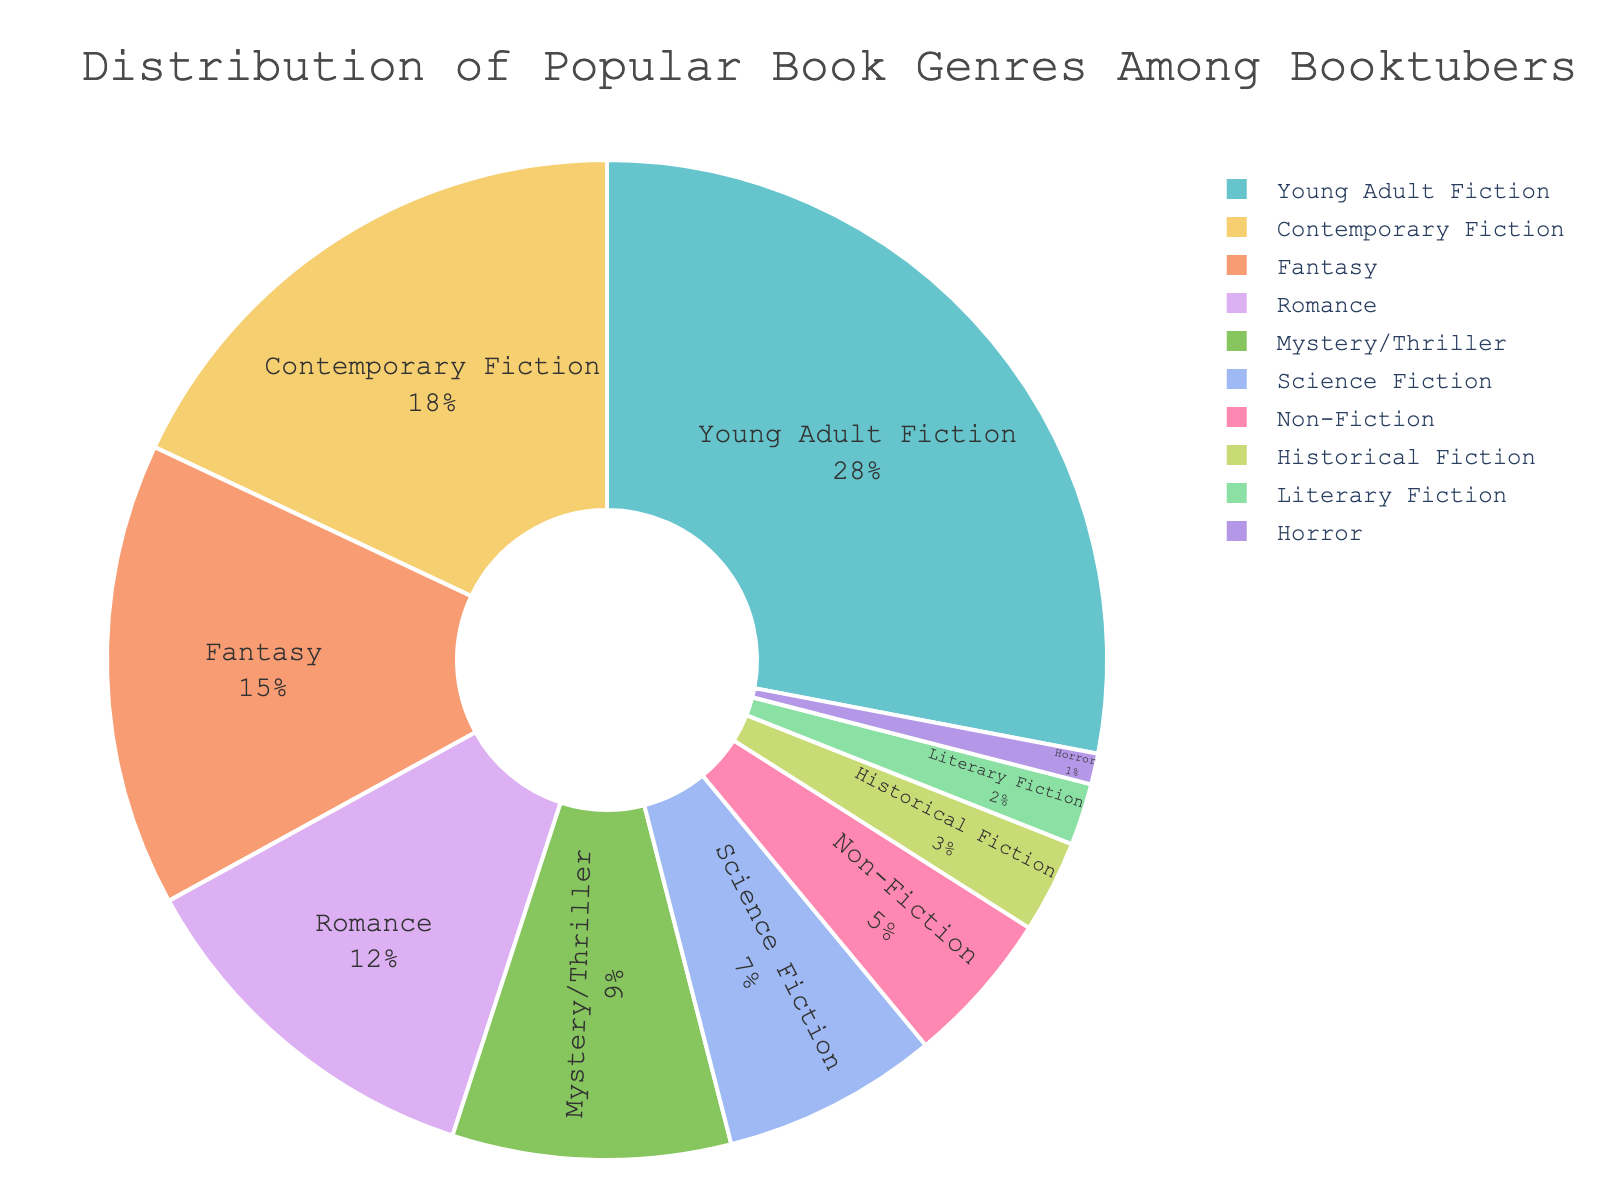Which genre is the most popular among booktubers? By looking at the figure, the largest segment of the pie chart represents Young Adult Fiction, which occupies 28% of the chart.
Answer: Young Adult Fiction How much more popular is Contemporary Fiction compared to Non-Fiction? Contemporary Fiction accounts for 18% and Non-Fiction accounts for 5%. Subtracting the two percentages gives the difference: 18% - 5% = 13%.
Answer: 13% What is the combined percentage of Mystery/Thriller and Science Fiction genres? Mystery/Thriller shows 9% and Science Fiction shows 7%. Adding them together yields: 9% + 7% = 16%.
Answer: 16% Which genre has the smallest representation among booktubers? The smallest segment of the pie chart represents Horror, which accounts for 1%.
Answer: Horror Are Fantasy and Romance genres equally popular? Fantasy constitutes 15% and Romance makes up 12% of the chart. Comparing the two indicates that Fantasy is more popular than Romance.
Answer: No What is the total percentage of genres that fall under 10% representation? The genres under 10% include Mystery/Thriller (9%), Science Fiction (7%), Non-Fiction (5%), Historical Fiction (3%), Literary Fiction (2%) and Horror (1%). Summing them: 9% + 7% + 5% + 3% + 2% + 1% = 27%.
Answer: 27% What is the difference between the combined percentage of the top three genres and the combined percentage of the bottom three genres? The top three genres are Young Adult Fiction (28%), Contemporary Fiction (18%), and Fantasy (15%) which sum to 28% + 18% + 15% = 61%. The bottom three genres are Historical Fiction (3%), Literary Fiction (2%), and Horror (1%), totalling 3% + 2% + 1% = 6%. The difference is: 61% - 6% = 55%.
Answer: 55% Is Romance genre more popular than Science Fiction? Romance is displayed at 12% and Science Fiction at 7% on the pie chart. Hence, Romance is more popular.
Answer: Yes What percentage of booktubers prefer genres other than Young Adult Fiction and Contemporary Fiction? Young Adult Fiction is 28% and Contemporary Fiction is 18%, totalling 28% + 18% = 46%. Therefore, the remaining percentage is 100% - 46% = 54%.
Answer: 54% What is the visual difference between the representation of Non-Fiction and Historical Fiction? The segment representing Non-Fiction is approximately 5%, whereas the one for Historical Fiction is 3%. Visually, the segment for Non-Fiction is slightly larger than that for Historical Fiction.
Answer: Non-Fiction is larger 